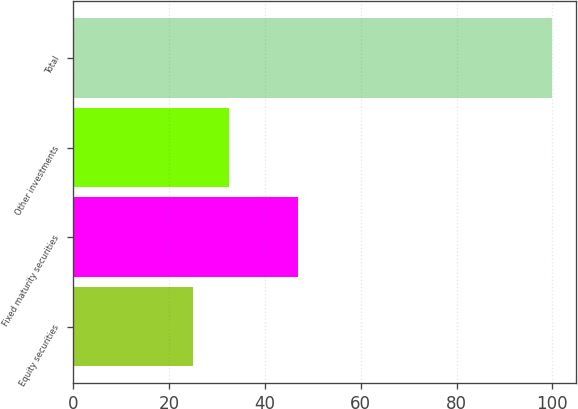Convert chart to OTSL. <chart><loc_0><loc_0><loc_500><loc_500><bar_chart><fcel>Equity securities<fcel>Fixed maturity securities<fcel>Other investments<fcel>Total<nl><fcel>25<fcel>47<fcel>32.5<fcel>100<nl></chart> 